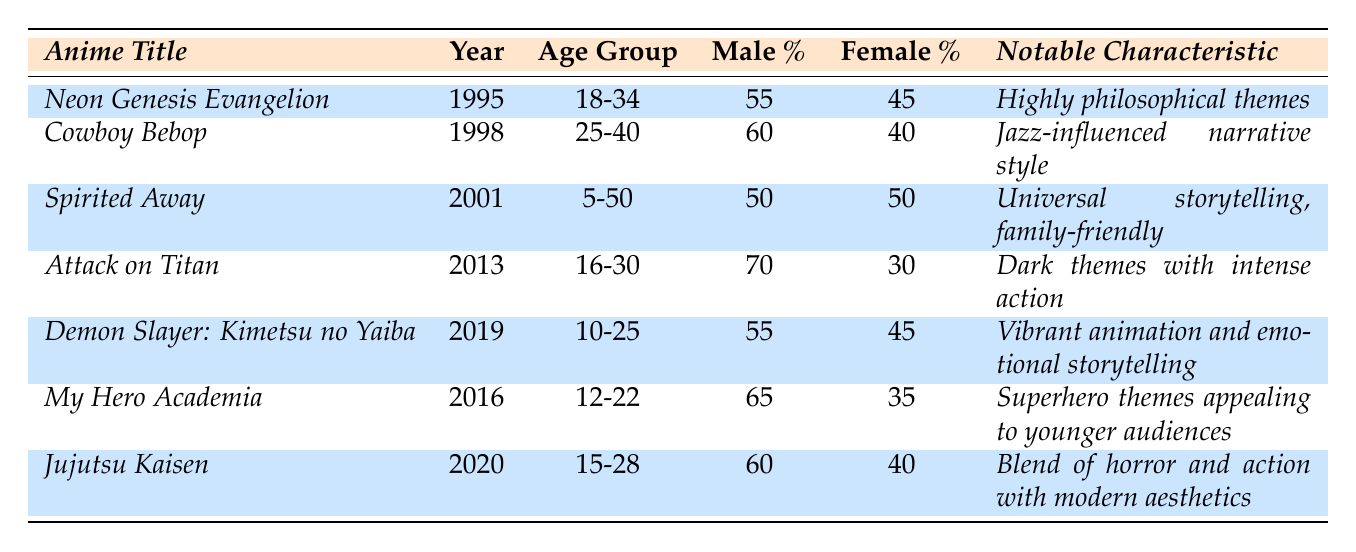What is the release year of "Cowboy Bebop"? The table lists "Cowboy Bebop" under the anime title column and the corresponding release year is next to it. Therefore, the release year is 1998.
Answer: 1998 What age group is targeted by "Attack on Titan"? In the table, the age group for "Attack on Titan" is explicitly listed alongside its title. The information shows it targets the age group of 16-30.
Answer: 16-30 Which anime has a male percentage higher than 65%? By checking the male percentages of each anime in the table, we can see that "Attack on Titan" (70%) and "My Hero Academia" (65%) meet or exceed 65%. Thus, "Attack on Titan" is the only anime with a percentage higher than 65%.
Answer: Attack on Titan Calculate the average male percentage for classic anime (before 2013). To find the average, we first identify the male percentages of classic anime: "Neon Genesis Evangelion" (55%), "Cowboy Bebop" (60%), and "Spirited Away" (50%). Adding these gives 55 + 60 + 50 = 165. Then, we divide by the 3 titles: 165 / 3 = 55.
Answer: 55 Is the notable characteristic of "Jujutsu Kaisen" focused on family-friendly themes? The notable characteristic for "Jujutsu Kaisen" is "Blend of horror and action with modern aesthetics," which is not focused on family-friendly themes. Thus, the answer is no.
Answer: No What is the difference in female percentage between "Demon Slayer" and "Attack on Titan"? The female percentage for "Demon Slayer" is 45% and for "Attack on Titan," it is 30%. To find the difference, we subtract: 45 - 30 = 15.
Answer: 15 Which anime has the most balanced gender percentage? The gender percentages for "Spirited Away" show an equal division of male and female audiences (50% each). Checking the other anime, "Spirited Away" is the only one with a perfectly balanced percentage.
Answer: Spirited Away Which age group appears most frequently among the newer mixed-media franchises (2013 and after)? The newer titles in the table are "Attack on Titan," "My Hero Academia," "Demon Slayer," and "Jujutsu Kaisen" with age groups being 16-30, 12-22, 10-25, and 15-28 respectively. The age groups overlap significantly; 12-22 and 10-25 target younger audiences, but no single age group is repeated among them.
Answer: No age group appears most frequently What is the notable characteristic of "Cowboy Bebop"? The table lists "Cowboy Bebop" under notable characteristics, which is described as "Jazz-influenced narrative style." Thus, we can directly refer to this description for the answer.
Answer: Jazz-influenced narrative style Overall, how do the male percentages of newer mixed-media franchises compare to those of classic anime? To determine this, we compare the male percentages of classic anime (average of 55%) to newer mixed-media franchises. Newer shows have male percentages of "Attack on Titan" (70%), "My Hero Academia" (65%), "Demon Slayer" (55%), and "Jujutsu Kaisen" (60%). Adding these gives 250%, and dividing by 4 gives an average of 62.5%. Since 62.5% is higher than 55%, we conclude that newer mixed-media franchises have higher male percentages overall.
Answer: Newer mixed-media franchises have higher male percentages 